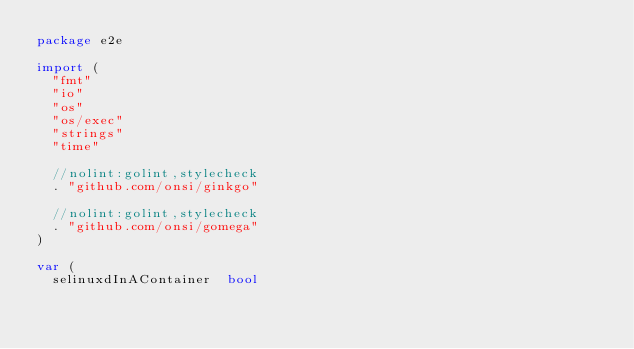<code> <loc_0><loc_0><loc_500><loc_500><_Go_>package e2e

import (
	"fmt"
	"io"
	"os"
	"os/exec"
	"strings"
	"time"

	//nolint:golint,stylecheck
	. "github.com/onsi/ginkgo"

	//nolint:golint,stylecheck
	. "github.com/onsi/gomega"
)

var (
	selinuxdInAContainer  bool</code> 